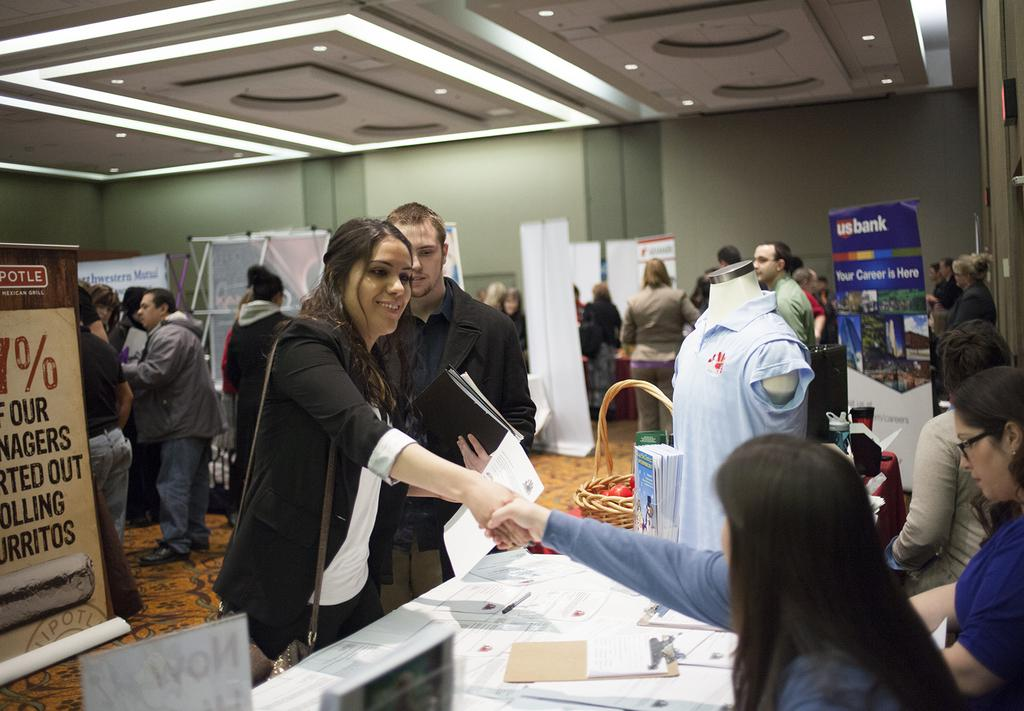<image>
Write a terse but informative summary of the picture. A US Bank sign hangs in the corner at this event. 